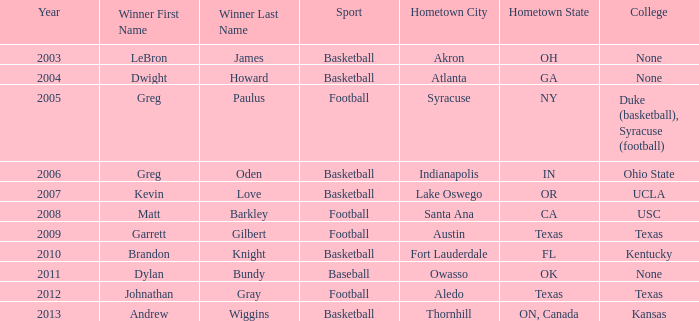What is the total number of Year, when Winner is "Johnathan Gray"? 1.0. 